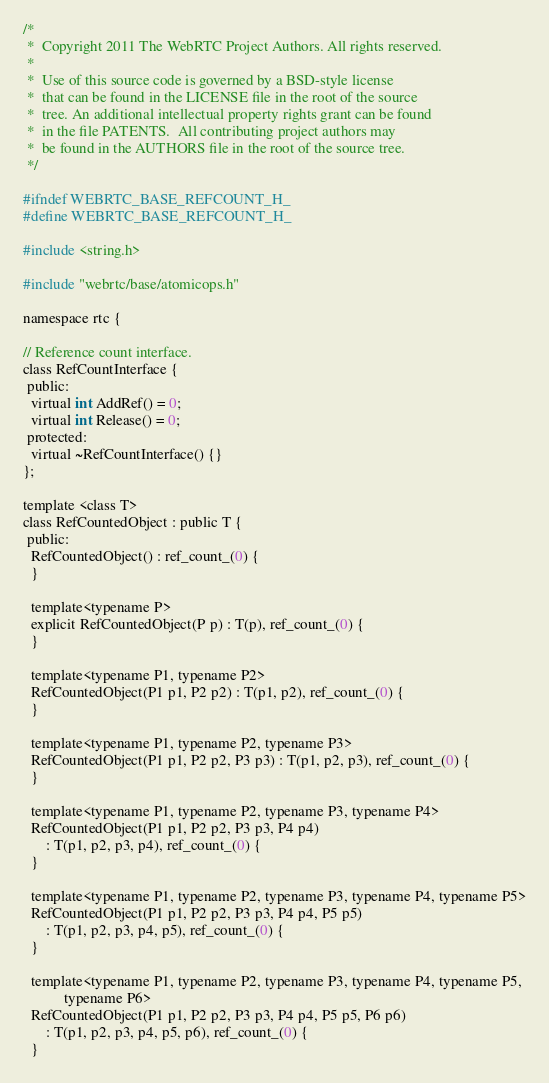Convert code to text. <code><loc_0><loc_0><loc_500><loc_500><_C_>/*
 *  Copyright 2011 The WebRTC Project Authors. All rights reserved.
 *
 *  Use of this source code is governed by a BSD-style license
 *  that can be found in the LICENSE file in the root of the source
 *  tree. An additional intellectual property rights grant can be found
 *  in the file PATENTS.  All contributing project authors may
 *  be found in the AUTHORS file in the root of the source tree.
 */

#ifndef WEBRTC_BASE_REFCOUNT_H_
#define WEBRTC_BASE_REFCOUNT_H_

#include <string.h>

#include "webrtc/base/atomicops.h"

namespace rtc {

// Reference count interface.
class RefCountInterface {
 public:
  virtual int AddRef() = 0;
  virtual int Release() = 0;
 protected:
  virtual ~RefCountInterface() {}
};

template <class T>
class RefCountedObject : public T {
 public:
  RefCountedObject() : ref_count_(0) {
  }

  template<typename P>
  explicit RefCountedObject(P p) : T(p), ref_count_(0) {
  }

  template<typename P1, typename P2>
  RefCountedObject(P1 p1, P2 p2) : T(p1, p2), ref_count_(0) {
  }

  template<typename P1, typename P2, typename P3>
  RefCountedObject(P1 p1, P2 p2, P3 p3) : T(p1, p2, p3), ref_count_(0) {
  }

  template<typename P1, typename P2, typename P3, typename P4>
  RefCountedObject(P1 p1, P2 p2, P3 p3, P4 p4)
      : T(p1, p2, p3, p4), ref_count_(0) {
  }

  template<typename P1, typename P2, typename P3, typename P4, typename P5>
  RefCountedObject(P1 p1, P2 p2, P3 p3, P4 p4, P5 p5)
      : T(p1, p2, p3, p4, p5), ref_count_(0) {
  }

  template<typename P1, typename P2, typename P3, typename P4, typename P5,
           typename P6>
  RefCountedObject(P1 p1, P2 p2, P3 p3, P4 p4, P5 p5, P6 p6)
      : T(p1, p2, p3, p4, p5, p6), ref_count_(0) {
  }
</code> 